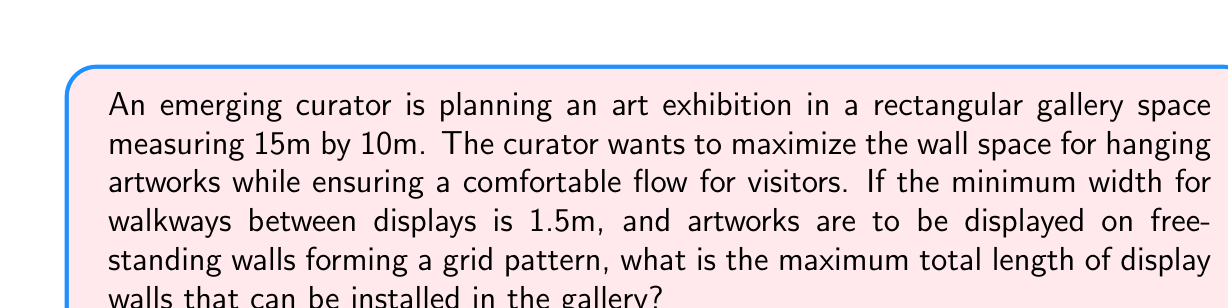Provide a solution to this math problem. Let's approach this problem step-by-step:

1) First, we need to determine the number of walkways in each direction:
   - In the 15m direction: $\frac{15}{1.5} = 10$, so we can have 9 walkways
   - In the 10m direction: $\frac{10}{1.5} = 6.67$, so we can have 5 walkways

2) This gives us a grid of 8 x 4 = 32 rectangles where we can place display walls.

3) Now, let's calculate the dimensions of each rectangle:
   - Length: $\frac{15}{9} = 1.67$m
   - Width: $\frac{10}{5} = 2$m

4) We can place walls along the edges of these rectangles. The number of possible wall placements is:
   - Vertical walls: 9 x 4 = 36
   - Horizontal walls: 8 x 5 = 40

5) The length of each wall:
   - Vertical walls: 2m each
   - Horizontal walls: 1.67m each

6) Total length of all possible walls:
   $$ L = (36 \times 2) + (40 \times 1.67) = 72 + 66.8 = 138.8\text{m} $$

Therefore, the maximum total length of display walls that can be installed is 138.8m.
Answer: 138.8m 